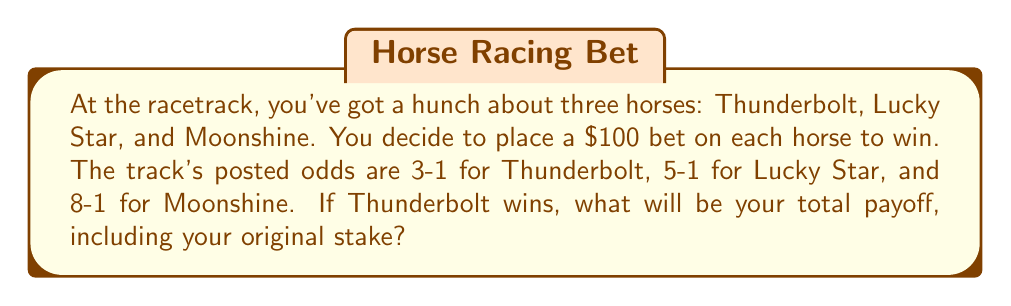Provide a solution to this math problem. Let's break this down step-by-step:

1) First, let's understand what the odds mean:
   - 3-1 odds mean for every $1 bet, you win $3 (plus your original stake)
   - 5-1 odds mean for every $1 bet, you win $5 (plus your original stake)
   - 8-1 odds mean for every $1 bet, you win $8 (plus your original stake)

2) You've bet $100 on each horse, so your total stake is $300.

3) If Thunderbolt wins (3-1 odds):
   - Your winning calculation: $100 × 3 = $300
   - You also get your original $100 stake back

4) Your payoff for Thunderbolt winning:
   $$ \text{Payoff} = \text{Winnings} + \text{Original Stake} $$
   $$ \text{Payoff} = $300 + $100 = $400 $$

5) However, you also placed bets on the other two horses, which you lose:
   $$ \text{Lost bets} = $100 + $100 = $200 $$

6) Your total payoff is therefore:
   $$ \text{Total Payoff} = \text{Winning bet payoff} - \text{Lost bets} + \text{Original winning stake} $$
   $$ \text{Total Payoff} = $400 - $200 + $100 = $300 $$

This $300 includes your original $100 stake on Thunderbolt.
Answer: $300 